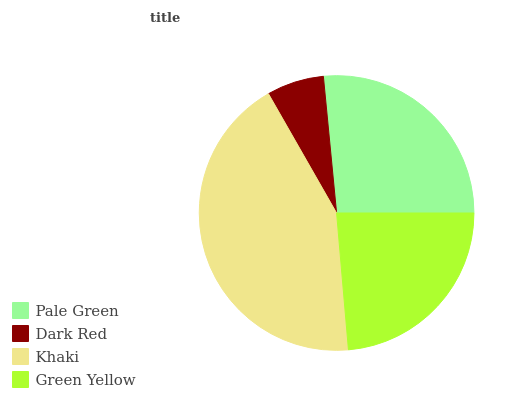Is Dark Red the minimum?
Answer yes or no. Yes. Is Khaki the maximum?
Answer yes or no. Yes. Is Khaki the minimum?
Answer yes or no. No. Is Dark Red the maximum?
Answer yes or no. No. Is Khaki greater than Dark Red?
Answer yes or no. Yes. Is Dark Red less than Khaki?
Answer yes or no. Yes. Is Dark Red greater than Khaki?
Answer yes or no. No. Is Khaki less than Dark Red?
Answer yes or no. No. Is Pale Green the high median?
Answer yes or no. Yes. Is Green Yellow the low median?
Answer yes or no. Yes. Is Dark Red the high median?
Answer yes or no. No. Is Pale Green the low median?
Answer yes or no. No. 